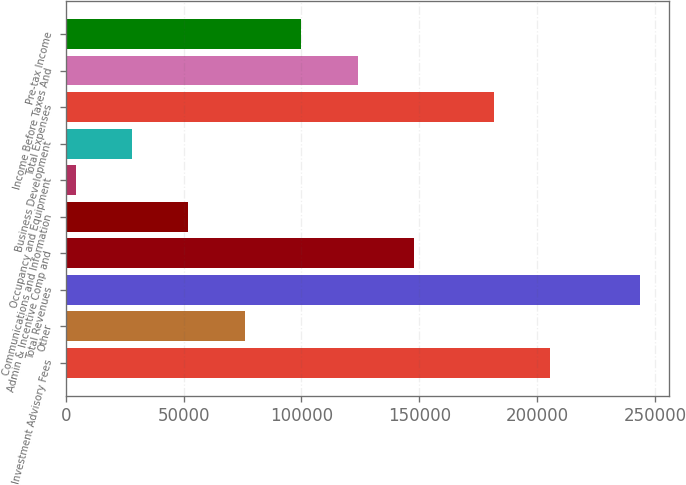Convert chart to OTSL. <chart><loc_0><loc_0><loc_500><loc_500><bar_chart><fcel>Investment Advisory Fees<fcel>Other<fcel>Total Revenues<fcel>Admin & Incentive Comp and<fcel>Communications and Information<fcel>Occupancy and Equipment<fcel>Business Development<fcel>Total Expenses<fcel>Income Before Taxes And<fcel>Pre-tax Income<nl><fcel>205626<fcel>76042.3<fcel>243609<fcel>147857<fcel>52104.2<fcel>4228<fcel>28166.1<fcel>181688<fcel>123918<fcel>99980.4<nl></chart> 